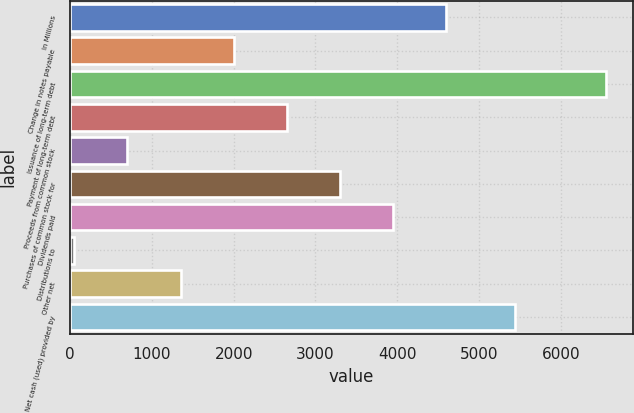<chart> <loc_0><loc_0><loc_500><loc_500><bar_chart><fcel>In Millions<fcel>Change in notes payable<fcel>Issuance of long-term debt<fcel>Payment of long-term debt<fcel>Proceeds from common stock<fcel>Purchases of common stock for<fcel>Dividends paid<fcel>Distributions to<fcel>Other net<fcel>Net cash (used) provided by<nl><fcel>4600.54<fcel>2001.26<fcel>6550<fcel>2651.08<fcel>701.62<fcel>3300.9<fcel>3950.72<fcel>51.8<fcel>1351.44<fcel>5445.5<nl></chart> 